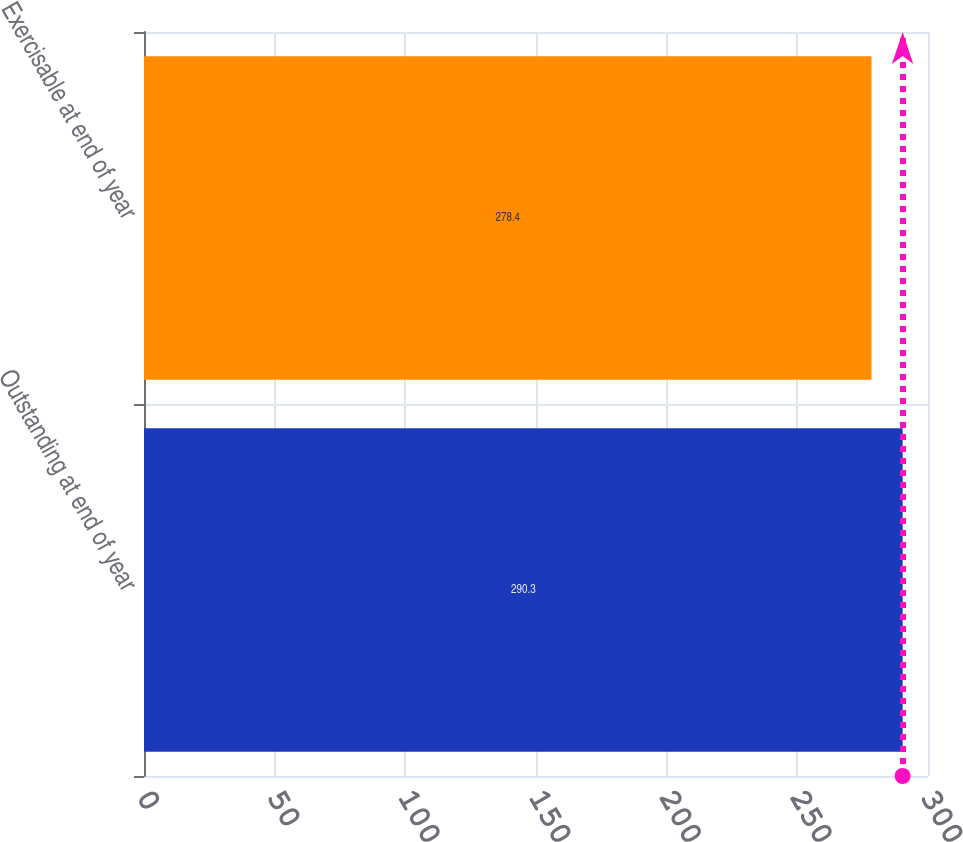<chart> <loc_0><loc_0><loc_500><loc_500><bar_chart><fcel>Outstanding at end of year<fcel>Exercisable at end of year<nl><fcel>290.3<fcel>278.4<nl></chart> 